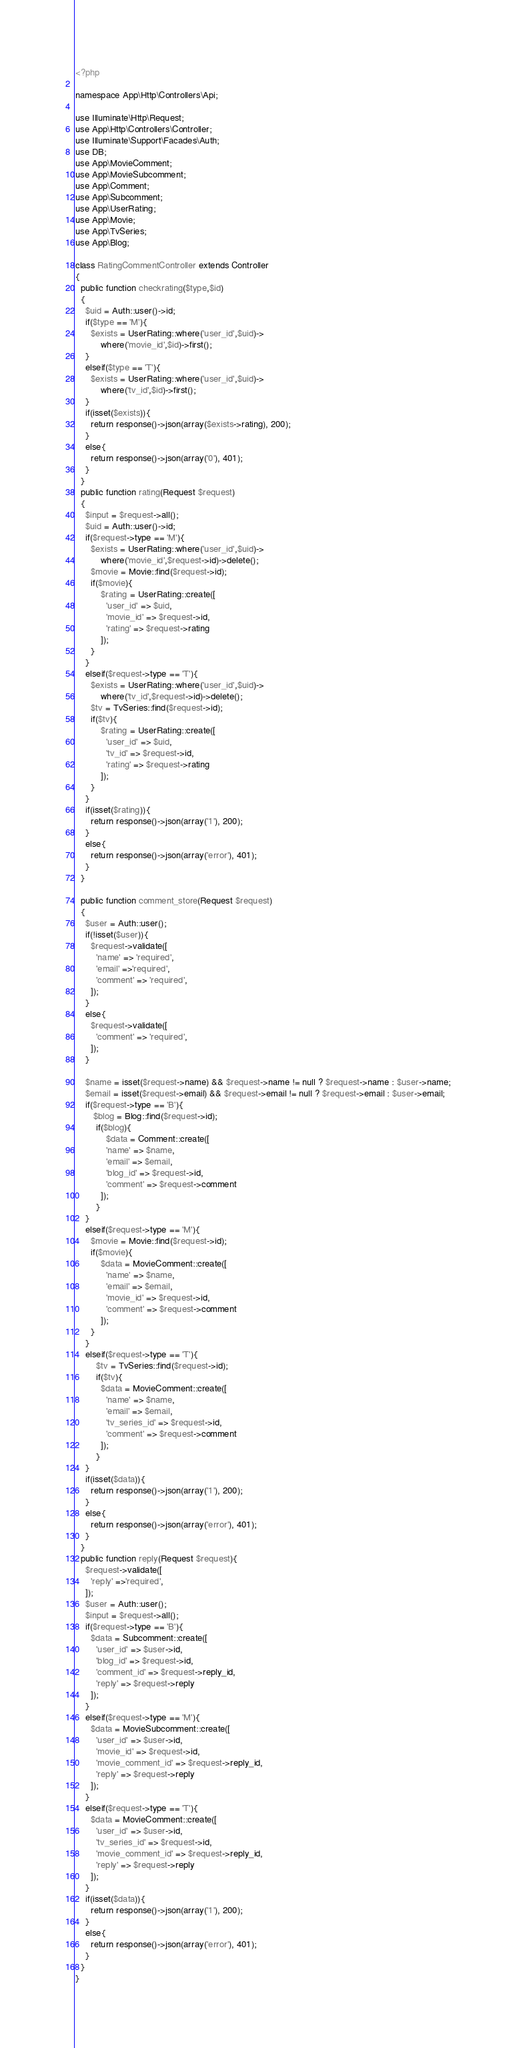Convert code to text. <code><loc_0><loc_0><loc_500><loc_500><_PHP_><?php

namespace App\Http\Controllers\Api;

use Illuminate\Http\Request;
use App\Http\Controllers\Controller;
use Illuminate\Support\Facades\Auth;
use DB;
use App\MovieComment;
use App\MovieSubcomment;
use App\Comment;
use App\Subcomment;
use App\UserRating;
use App\Movie;
use App\TvSeries;
use App\Blog;

class RatingCommentController extends Controller
{ 
  public function checkrating($type,$id)
  {      
    $uid = Auth::user()->id;
    if($type == 'M'){
      $exists = UserRating::where('user_id',$uid)->
          where('movie_id',$id)->first();
    }
    elseif($type == 'T'){
      $exists = UserRating::where('user_id',$uid)->
          where('tv_id',$id)->first();
    }
    if(isset($exists)){
      return response()->json(array($exists->rating), 200); 
    }
    else{
      return response()->json(array('0'), 401);  
    }
  }
  public function rating(Request $request)
  {      
    $input = $request->all();
    $uid = Auth::user()->id;
    if($request->type == 'M'){
      $exists = UserRating::where('user_id',$uid)->
          where('movie_id',$request->id)->delete();
      $movie = Movie::find($request->id);
      if($movie){
          $rating = UserRating::create([
            'user_id' => $uid,
            'movie_id' => $request->id,
            'rating' => $request->rating
          ]);
      }
    }
    elseif($request->type == 'T'){
      $exists = UserRating::where('user_id',$uid)->
          where('tv_id',$request->id)->delete();
      $tv = TvSeries::find($request->id);
      if($tv){
          $rating = UserRating::create([
            'user_id' => $uid,
            'tv_id' => $request->id,
            'rating' => $request->rating
          ]);
      }
    }
    if(isset($rating)){
      return response()->json(array('1'), 200); 
    }
    else{
      return response()->json(array('error'), 401);  
    }
  }
  
  public function comment_store(Request $request)
  {
    $user = Auth::user();
    if(!isset($user)){
      $request->validate([
        'name' => 'required',  
        'email' =>'required',   
        'comment' => 'required',      
      ]);
    }
    else{
      $request->validate([
        'comment' => 'required',      
      ]);
    }

    $name = isset($request->name) && $request->name != null ? $request->name : $user->name; 
    $email = isset($request->email) && $request->email != null ? $request->email : $user->email; 
    if($request->type == 'B'){
       $blog = Blog::find($request->id);
        if($blog){
            $data = Comment::create([
            'name' => $name,
            'email' => $email,
            'blog_id' => $request->id,
            'comment' => $request->comment   
          ]);
        }
    }
    elseif($request->type == 'M'){
      $movie = Movie::find($request->id);
      if($movie){
          $data = MovieComment::create([
            'name' => $name,
            'email' => $email,
            'movie_id' => $request->id,
            'comment' => $request->comment   
          ]);
      }
    }    
    elseif($request->type == 'T'){
        $tv = TvSeries::find($request->id);
        if($tv){
          $data = MovieComment::create([
            'name' => $name,
            'email' => $email,
            'tv_series_id' => $request->id,
            'comment' => $request->comment   
          ]);
        }
    }    
    if(isset($data)){
      return response()->json(array('1'), 200); 
    }
    else{
      return response()->json(array('error'), 401);  
    }   
  }
  public function reply(Request $request){
    $request->validate([
      'reply' =>'required',
    ]);    
    $user = Auth::user();
    $input = $request->all();
    if($request->type == 'B'){
      $data = Subcomment::create([
        'user_id' => $user->id,
        'blog_id' => $request->id,
        'comment_id' => $request->reply_id,
        'reply' => $request->reply   
      ]);
    }
    elseif($request->type == 'M'){
      $data = MovieSubcomment::create([
        'user_id' => $user->id,
        'movie_id' => $request->id,
        'movie_comment_id' => $request->reply_id,
        'reply' => $request->reply 
      ]);
    }    
    elseif($request->type == 'T'){
      $data = MovieComment::create([
        'user_id' => $user->id,
        'tv_series_id' => $request->id,
        'movie_comment_id' => $request->reply_id,
        'reply' => $request->reply   
      ]);
    }    
    if(isset($data)){
      return response()->json(array('1'), 200); 
    }
    else{
      return response()->json(array('error'), 401);  
    }   
  }
}</code> 